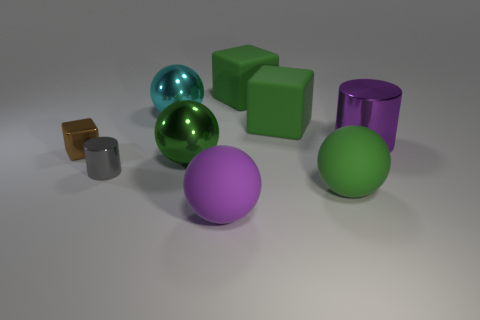There is a cyan thing; is its size the same as the cube that is left of the cyan metallic object?
Keep it short and to the point. No. There is a thing that is both on the left side of the cyan ball and behind the small gray object; what shape is it?
Give a very brief answer. Cube. How many large objects are either blue cylinders or green objects?
Your answer should be compact. 4. Is the number of big shiny things that are on the left side of the purple cylinder the same as the number of big cyan metal things in front of the gray metallic cylinder?
Provide a succinct answer. No. What number of other things are the same color as the big shiny cylinder?
Provide a succinct answer. 1. Are there an equal number of big purple rubber objects that are right of the shiny block and big metallic cylinders?
Keep it short and to the point. Yes. Does the gray shiny cylinder have the same size as the brown object?
Your response must be concise. Yes. What is the block that is right of the big cyan metallic sphere and in front of the cyan thing made of?
Offer a very short reply. Rubber. How many rubber objects have the same shape as the brown metal thing?
Provide a short and direct response. 2. What material is the purple sphere that is on the right side of the tiny shiny cylinder?
Ensure brevity in your answer.  Rubber. 